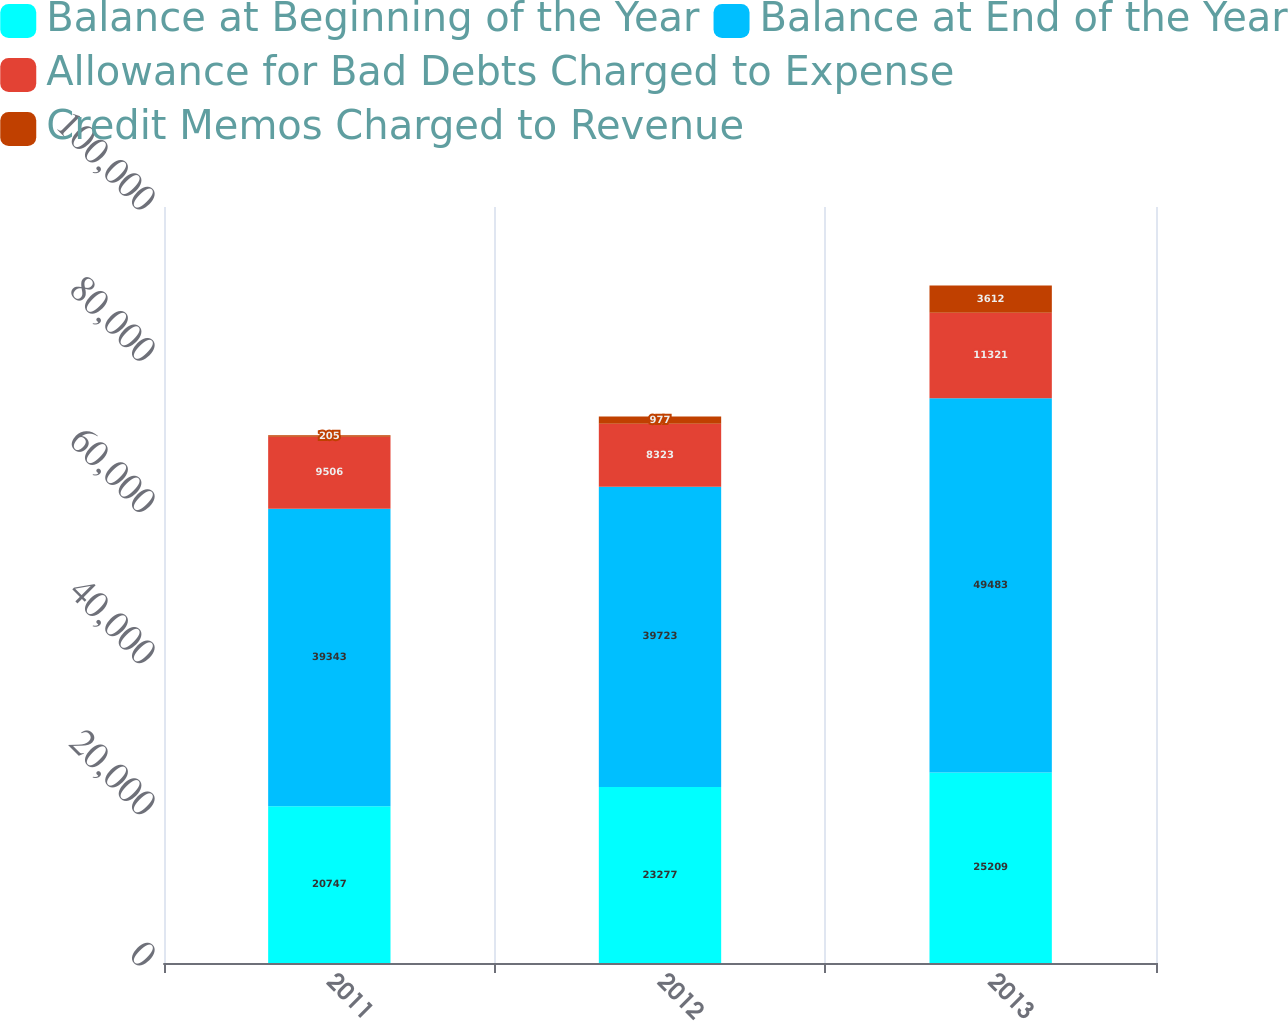<chart> <loc_0><loc_0><loc_500><loc_500><stacked_bar_chart><ecel><fcel>2011<fcel>2012<fcel>2013<nl><fcel>Balance at Beginning of the Year<fcel>20747<fcel>23277<fcel>25209<nl><fcel>Balance at End of the Year<fcel>39343<fcel>39723<fcel>49483<nl><fcel>Allowance for Bad Debts Charged to Expense<fcel>9506<fcel>8323<fcel>11321<nl><fcel>Credit Memos Charged to Revenue<fcel>205<fcel>977<fcel>3612<nl></chart> 